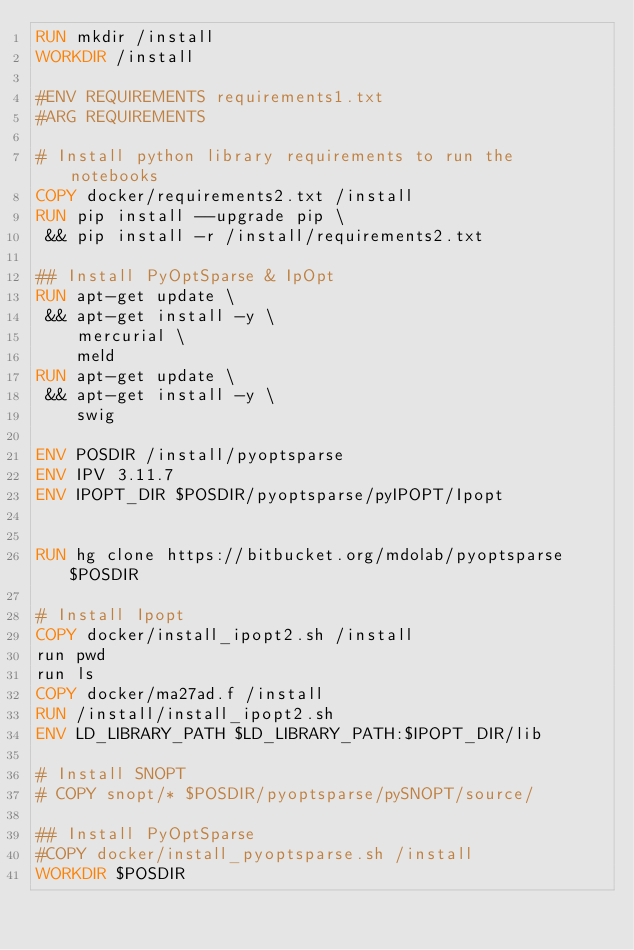<code> <loc_0><loc_0><loc_500><loc_500><_Dockerfile_>RUN mkdir /install
WORKDIR /install

#ENV REQUIREMENTS requirements1.txt
#ARG REQUIREMENTS

# Install python library requirements to run the notebooks
COPY docker/requirements2.txt /install
RUN pip install --upgrade pip \
 && pip install -r /install/requirements2.txt

## Install PyOptSparse & IpOpt
RUN apt-get update \
 && apt-get install -y \
    mercurial \
    meld
RUN apt-get update \
 && apt-get install -y \
    swig

ENV POSDIR /install/pyoptsparse
ENV IPV 3.11.7
ENV IPOPT_DIR $POSDIR/pyoptsparse/pyIPOPT/Ipopt


RUN hg clone https://bitbucket.org/mdolab/pyoptsparse $POSDIR

# Install Ipopt
COPY docker/install_ipopt2.sh /install
run pwd
run ls
COPY docker/ma27ad.f /install
RUN /install/install_ipopt2.sh
ENV LD_LIBRARY_PATH $LD_LIBRARY_PATH:$IPOPT_DIR/lib

# Install SNOPT
# COPY snopt/* $POSDIR/pyoptsparse/pySNOPT/source/

## Install PyOptSparse
#COPY docker/install_pyoptsparse.sh /install
WORKDIR $POSDIR

</code> 